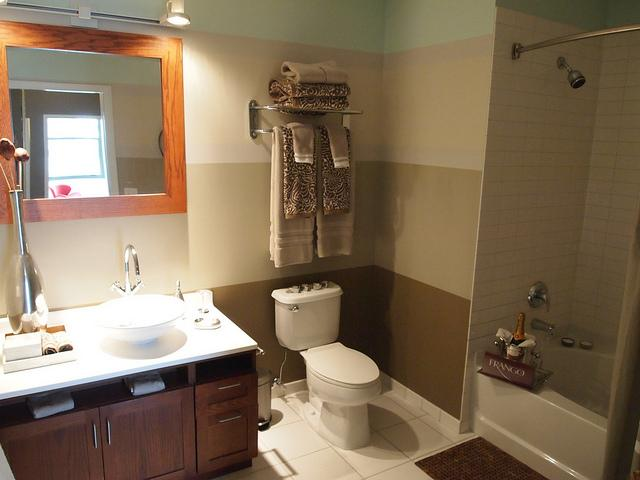What color is the border around the edges of the mirror? brown 